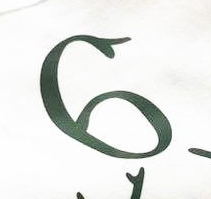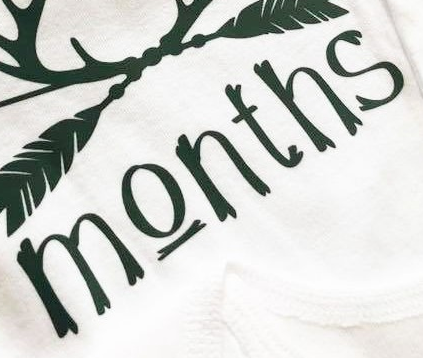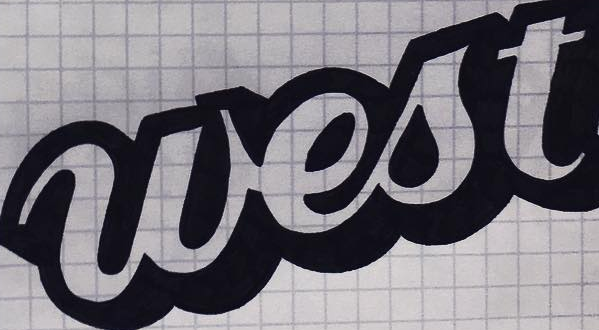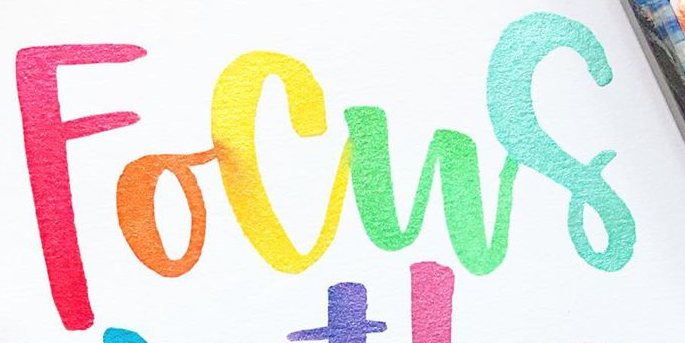Transcribe the words shown in these images in order, separated by a semicolon. 6; Months; west; Focus 